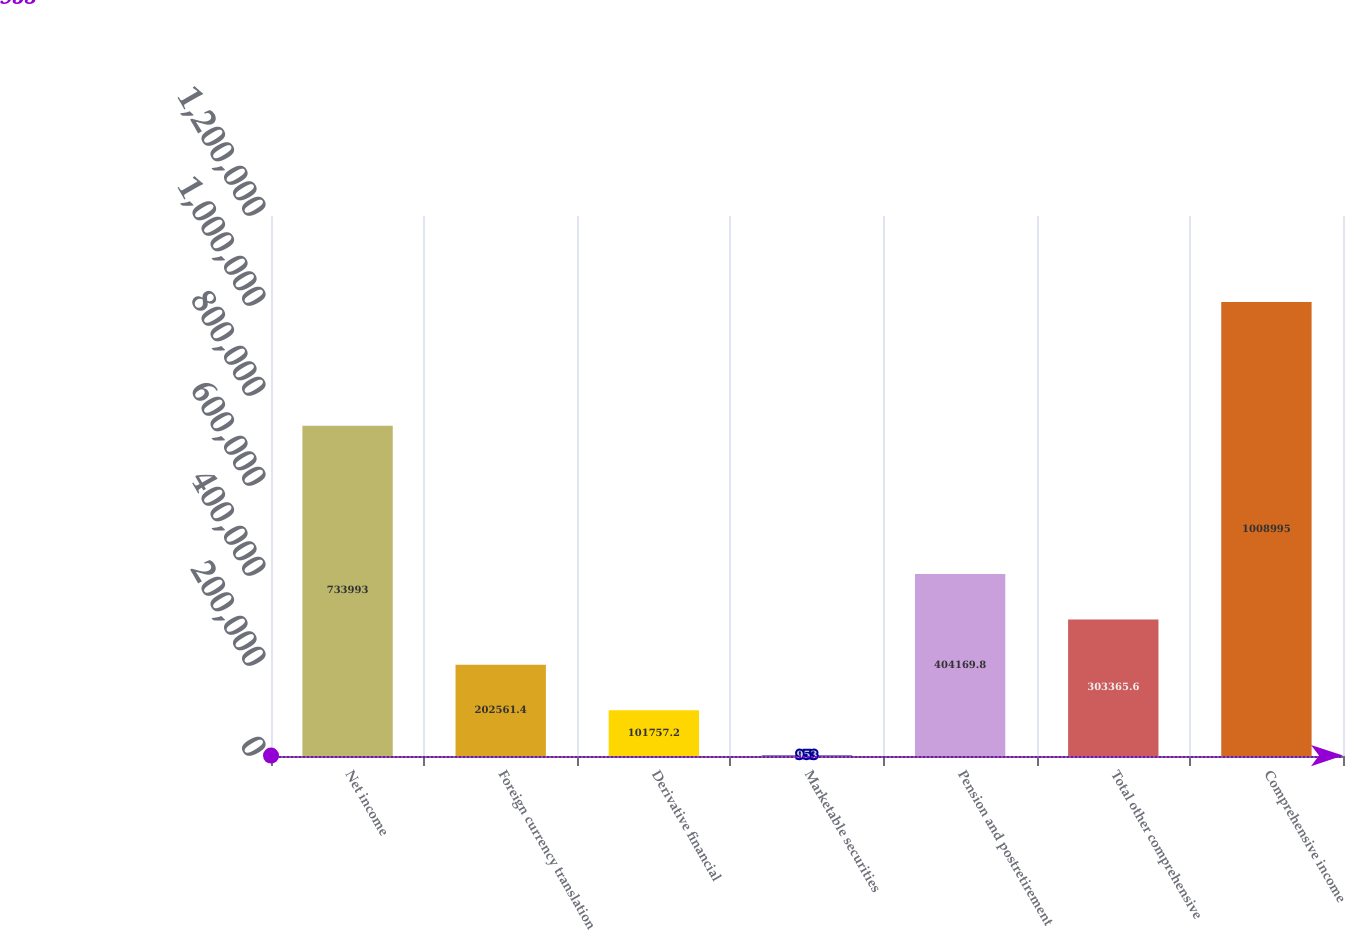Convert chart. <chart><loc_0><loc_0><loc_500><loc_500><bar_chart><fcel>Net income<fcel>Foreign currency translation<fcel>Derivative financial<fcel>Marketable securities<fcel>Pension and postretirement<fcel>Total other comprehensive<fcel>Comprehensive income<nl><fcel>733993<fcel>202561<fcel>101757<fcel>953<fcel>404170<fcel>303366<fcel>1.009e+06<nl></chart> 